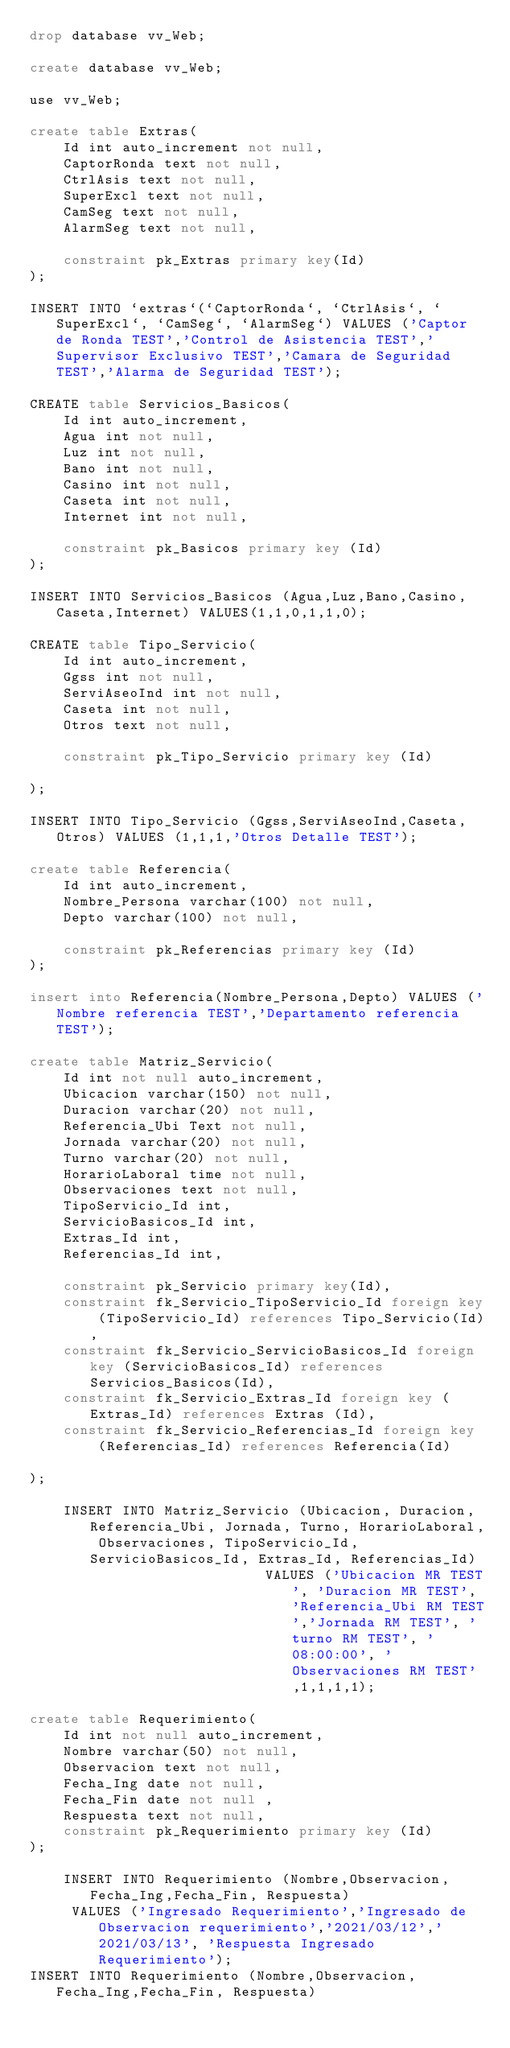<code> <loc_0><loc_0><loc_500><loc_500><_SQL_>drop database vv_Web;

create database vv_Web;

use vv_Web;

create table Extras(
	Id int auto_increment not null,
	CaptorRonda text not null,
	CtrlAsis text not null,
	SuperExcl text not null,
	CamSeg text not null,
	AlarmSeg text not null,

	constraint pk_Extras primary key(Id)
);

INSERT INTO `extras`(`CaptorRonda`, `CtrlAsis`, `SuperExcl`, `CamSeg`, `AlarmSeg`) VALUES ('Captor de Ronda TEST','Control de Asistencia TEST','Supervisor Exclusivo TEST','Camara de Seguridad TEST','Alarma de Seguridad TEST');

CREATE table Servicios_Basicos(
	Id int auto_increment,
	Agua int not null,
	Luz int not null,
	Bano int not null,
	Casino int not null,
	Caseta int not null,
	Internet int not null,

	constraint pk_Basicos primary key (Id)
);

INSERT INTO Servicios_Basicos (Agua,Luz,Bano,Casino,Caseta,Internet) VALUES(1,1,0,1,1,0);

CREATE table Tipo_Servicio(
	Id int auto_increment,
	Ggss int not null,
	ServiAseoInd int not null,
	Caseta int not null,
	Otros text not null,

	constraint pk_Tipo_Servicio primary key (Id)

);

INSERT INTO Tipo_Servicio (Ggss,ServiAseoInd,Caseta,Otros) VALUES (1,1,1,'Otros Detalle TEST');

create table Referencia(
	Id int auto_increment,
	Nombre_Persona varchar(100) not null,
	Depto varchar(100) not null,

	constraint pk_Referencias primary key (Id)
);

insert into Referencia(Nombre_Persona,Depto) VALUES ('Nombre referencia TEST','Departamento referencia TEST');

create table Matriz_Servicio(
	Id int not null auto_increment,
	Ubicacion varchar(150) not null,
	Duracion varchar(20) not null,
	Referencia_Ubi Text not null,
	Jornada varchar(20) not null,
	Turno varchar(20) not null,
	HorarioLaboral time not null,
	Observaciones text not null,
	TipoServicio_Id int,
	ServicioBasicos_Id int,
	Extras_Id int,
	Referencias_Id int,

	constraint pk_Servicio primary key(Id),
	constraint fk_Servicio_TipoServicio_Id foreign key (TipoServicio_Id) references Tipo_Servicio(Id),
	constraint fk_Servicio_ServicioBasicos_Id foreign key (ServicioBasicos_Id) references Servicios_Basicos(Id),
	constraint fk_Servicio_Extras_Id foreign key (Extras_Id) references Extras (Id),
	constraint fk_Servicio_Referencias_Id foreign key  (Referencias_Id) references Referencia(Id)

);

	INSERT INTO Matriz_Servicio (Ubicacion, Duracion, Referencia_Ubi, Jornada, Turno, HorarioLaboral, Observaciones, TipoServicio_Id, ServicioBasicos_Id, Extras_Id, Referencias_Id)
		 					VALUES ('Ubicacion MR TEST', 'Duracion MR TEST', 'Referencia_Ubi RM TEST','Jornada RM TEST', 'turno RM TEST', '08:00:00', 'Observaciones RM TEST',1,1,1,1);

create table Requerimiento(
	Id int not null auto_increment,
	Nombre varchar(50) not null,
	Observacion text not null,
	Fecha_Ing date not null,
	Fecha_Fin date not null ,
	Respuesta text not null,
	constraint pk_Requerimiento primary key (Id)
);

	INSERT INTO Requerimiento (Nombre,Observacion,Fecha_Ing,Fecha_Fin, Respuesta)
	 VALUES ('Ingresado Requerimiento','Ingresado de Observacion requerimiento','2021/03/12','2021/03/13', 'Respuesta Ingresado Requerimiento');
INSERT INTO Requerimiento (Nombre,Observacion,Fecha_Ing,Fecha_Fin, Respuesta)</code> 